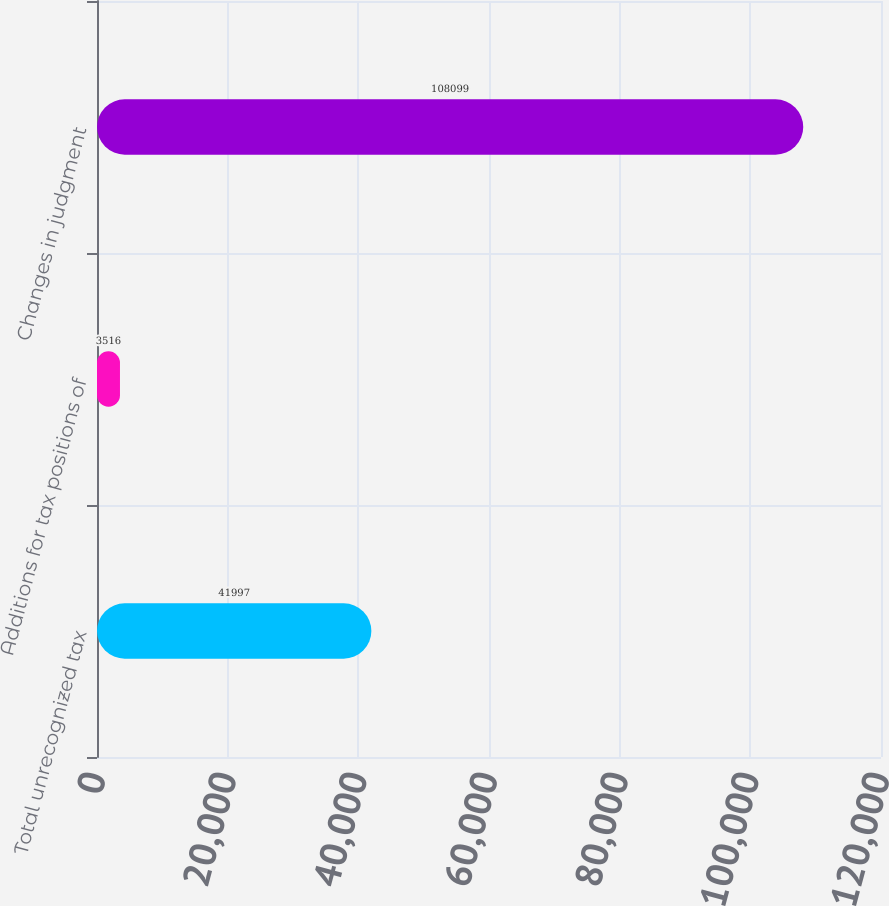Convert chart to OTSL. <chart><loc_0><loc_0><loc_500><loc_500><bar_chart><fcel>Total unrecognized tax<fcel>Additions for tax positions of<fcel>Changes in judgment<nl><fcel>41997<fcel>3516<fcel>108099<nl></chart> 